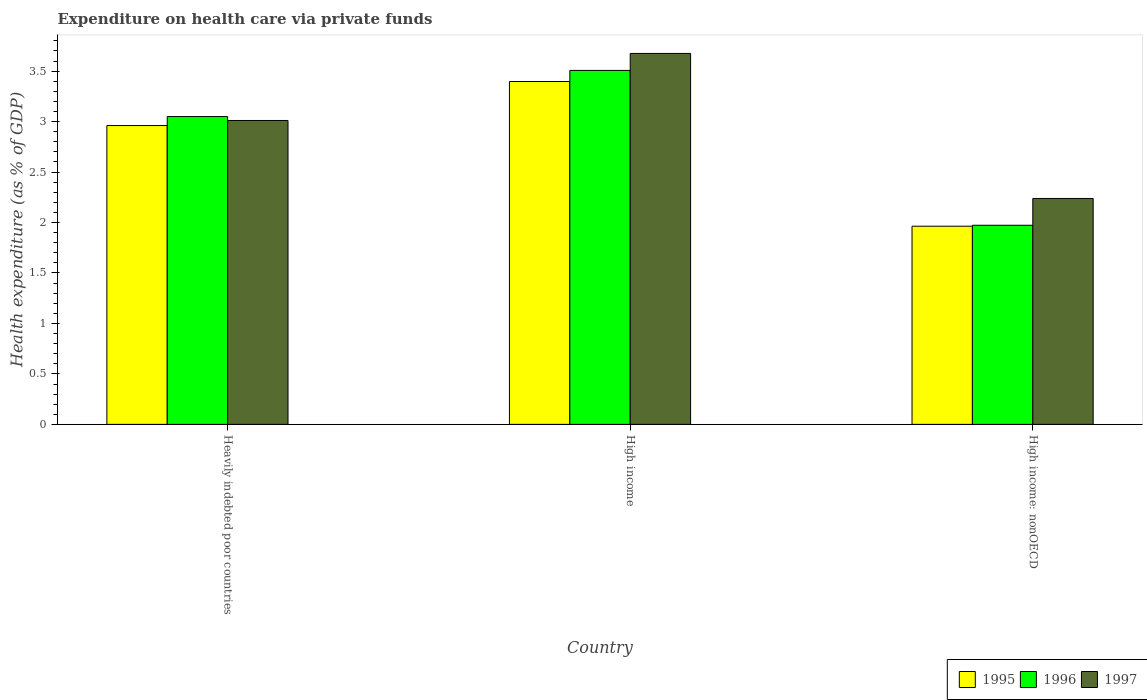How many groups of bars are there?
Your response must be concise. 3. Are the number of bars on each tick of the X-axis equal?
Ensure brevity in your answer.  Yes. How many bars are there on the 2nd tick from the left?
Provide a short and direct response. 3. How many bars are there on the 2nd tick from the right?
Offer a very short reply. 3. What is the label of the 2nd group of bars from the left?
Ensure brevity in your answer.  High income. In how many cases, is the number of bars for a given country not equal to the number of legend labels?
Your response must be concise. 0. What is the expenditure made on health care in 1997 in Heavily indebted poor countries?
Your response must be concise. 3.01. Across all countries, what is the maximum expenditure made on health care in 1997?
Your response must be concise. 3.68. Across all countries, what is the minimum expenditure made on health care in 1997?
Offer a very short reply. 2.24. In which country was the expenditure made on health care in 1995 minimum?
Your answer should be compact. High income: nonOECD. What is the total expenditure made on health care in 1996 in the graph?
Ensure brevity in your answer.  8.53. What is the difference between the expenditure made on health care in 1996 in High income and that in High income: nonOECD?
Ensure brevity in your answer.  1.53. What is the difference between the expenditure made on health care in 1996 in Heavily indebted poor countries and the expenditure made on health care in 1997 in High income: nonOECD?
Provide a short and direct response. 0.81. What is the average expenditure made on health care in 1997 per country?
Ensure brevity in your answer.  2.98. What is the difference between the expenditure made on health care of/in 1996 and expenditure made on health care of/in 1995 in Heavily indebted poor countries?
Provide a short and direct response. 0.09. In how many countries, is the expenditure made on health care in 1996 greater than 1.5 %?
Provide a short and direct response. 3. What is the ratio of the expenditure made on health care in 1995 in Heavily indebted poor countries to that in High income?
Ensure brevity in your answer.  0.87. Is the expenditure made on health care in 1995 in Heavily indebted poor countries less than that in High income: nonOECD?
Make the answer very short. No. Is the difference between the expenditure made on health care in 1996 in Heavily indebted poor countries and High income: nonOECD greater than the difference between the expenditure made on health care in 1995 in Heavily indebted poor countries and High income: nonOECD?
Give a very brief answer. Yes. What is the difference between the highest and the second highest expenditure made on health care in 1995?
Give a very brief answer. -1. What is the difference between the highest and the lowest expenditure made on health care in 1996?
Your answer should be very brief. 1.53. In how many countries, is the expenditure made on health care in 1996 greater than the average expenditure made on health care in 1996 taken over all countries?
Offer a terse response. 2. Is the sum of the expenditure made on health care in 1996 in High income and High income: nonOECD greater than the maximum expenditure made on health care in 1995 across all countries?
Your answer should be compact. Yes. What does the 2nd bar from the right in Heavily indebted poor countries represents?
Provide a succinct answer. 1996. Is it the case that in every country, the sum of the expenditure made on health care in 1995 and expenditure made on health care in 1996 is greater than the expenditure made on health care in 1997?
Provide a short and direct response. Yes. Are all the bars in the graph horizontal?
Your answer should be very brief. No. How many countries are there in the graph?
Provide a succinct answer. 3. Does the graph contain grids?
Offer a terse response. No. Where does the legend appear in the graph?
Your answer should be very brief. Bottom right. How many legend labels are there?
Make the answer very short. 3. What is the title of the graph?
Provide a succinct answer. Expenditure on health care via private funds. Does "2012" appear as one of the legend labels in the graph?
Offer a terse response. No. What is the label or title of the Y-axis?
Give a very brief answer. Health expenditure (as % of GDP). What is the Health expenditure (as % of GDP) in 1995 in Heavily indebted poor countries?
Offer a very short reply. 2.96. What is the Health expenditure (as % of GDP) in 1996 in Heavily indebted poor countries?
Offer a very short reply. 3.05. What is the Health expenditure (as % of GDP) in 1997 in Heavily indebted poor countries?
Provide a short and direct response. 3.01. What is the Health expenditure (as % of GDP) in 1995 in High income?
Offer a terse response. 3.4. What is the Health expenditure (as % of GDP) of 1996 in High income?
Your answer should be compact. 3.51. What is the Health expenditure (as % of GDP) of 1997 in High income?
Your response must be concise. 3.68. What is the Health expenditure (as % of GDP) of 1995 in High income: nonOECD?
Provide a short and direct response. 1.96. What is the Health expenditure (as % of GDP) of 1996 in High income: nonOECD?
Your answer should be very brief. 1.97. What is the Health expenditure (as % of GDP) in 1997 in High income: nonOECD?
Keep it short and to the point. 2.24. Across all countries, what is the maximum Health expenditure (as % of GDP) of 1995?
Offer a terse response. 3.4. Across all countries, what is the maximum Health expenditure (as % of GDP) of 1996?
Ensure brevity in your answer.  3.51. Across all countries, what is the maximum Health expenditure (as % of GDP) in 1997?
Provide a short and direct response. 3.68. Across all countries, what is the minimum Health expenditure (as % of GDP) in 1995?
Ensure brevity in your answer.  1.96. Across all countries, what is the minimum Health expenditure (as % of GDP) in 1996?
Make the answer very short. 1.97. Across all countries, what is the minimum Health expenditure (as % of GDP) in 1997?
Give a very brief answer. 2.24. What is the total Health expenditure (as % of GDP) of 1995 in the graph?
Ensure brevity in your answer.  8.32. What is the total Health expenditure (as % of GDP) in 1996 in the graph?
Your answer should be very brief. 8.53. What is the total Health expenditure (as % of GDP) of 1997 in the graph?
Make the answer very short. 8.93. What is the difference between the Health expenditure (as % of GDP) in 1995 in Heavily indebted poor countries and that in High income?
Your answer should be compact. -0.44. What is the difference between the Health expenditure (as % of GDP) of 1996 in Heavily indebted poor countries and that in High income?
Offer a terse response. -0.46. What is the difference between the Health expenditure (as % of GDP) of 1997 in Heavily indebted poor countries and that in High income?
Offer a very short reply. -0.66. What is the difference between the Health expenditure (as % of GDP) in 1997 in Heavily indebted poor countries and that in High income: nonOECD?
Provide a short and direct response. 0.77. What is the difference between the Health expenditure (as % of GDP) of 1995 in High income and that in High income: nonOECD?
Provide a short and direct response. 1.43. What is the difference between the Health expenditure (as % of GDP) of 1996 in High income and that in High income: nonOECD?
Your answer should be very brief. 1.53. What is the difference between the Health expenditure (as % of GDP) in 1997 in High income and that in High income: nonOECD?
Offer a very short reply. 1.44. What is the difference between the Health expenditure (as % of GDP) of 1995 in Heavily indebted poor countries and the Health expenditure (as % of GDP) of 1996 in High income?
Provide a succinct answer. -0.55. What is the difference between the Health expenditure (as % of GDP) of 1995 in Heavily indebted poor countries and the Health expenditure (as % of GDP) of 1997 in High income?
Keep it short and to the point. -0.71. What is the difference between the Health expenditure (as % of GDP) of 1996 in Heavily indebted poor countries and the Health expenditure (as % of GDP) of 1997 in High income?
Give a very brief answer. -0.63. What is the difference between the Health expenditure (as % of GDP) of 1995 in Heavily indebted poor countries and the Health expenditure (as % of GDP) of 1996 in High income: nonOECD?
Give a very brief answer. 0.99. What is the difference between the Health expenditure (as % of GDP) in 1995 in Heavily indebted poor countries and the Health expenditure (as % of GDP) in 1997 in High income: nonOECD?
Provide a short and direct response. 0.72. What is the difference between the Health expenditure (as % of GDP) in 1996 in Heavily indebted poor countries and the Health expenditure (as % of GDP) in 1997 in High income: nonOECD?
Keep it short and to the point. 0.81. What is the difference between the Health expenditure (as % of GDP) of 1995 in High income and the Health expenditure (as % of GDP) of 1996 in High income: nonOECD?
Offer a very short reply. 1.42. What is the difference between the Health expenditure (as % of GDP) of 1995 in High income and the Health expenditure (as % of GDP) of 1997 in High income: nonOECD?
Provide a short and direct response. 1.16. What is the difference between the Health expenditure (as % of GDP) of 1996 in High income and the Health expenditure (as % of GDP) of 1997 in High income: nonOECD?
Provide a succinct answer. 1.27. What is the average Health expenditure (as % of GDP) of 1995 per country?
Offer a very short reply. 2.77. What is the average Health expenditure (as % of GDP) of 1996 per country?
Provide a short and direct response. 2.84. What is the average Health expenditure (as % of GDP) in 1997 per country?
Keep it short and to the point. 2.98. What is the difference between the Health expenditure (as % of GDP) of 1995 and Health expenditure (as % of GDP) of 1996 in Heavily indebted poor countries?
Make the answer very short. -0.09. What is the difference between the Health expenditure (as % of GDP) of 1995 and Health expenditure (as % of GDP) of 1997 in Heavily indebted poor countries?
Your answer should be very brief. -0.05. What is the difference between the Health expenditure (as % of GDP) of 1996 and Health expenditure (as % of GDP) of 1997 in Heavily indebted poor countries?
Make the answer very short. 0.04. What is the difference between the Health expenditure (as % of GDP) of 1995 and Health expenditure (as % of GDP) of 1996 in High income?
Make the answer very short. -0.11. What is the difference between the Health expenditure (as % of GDP) in 1995 and Health expenditure (as % of GDP) in 1997 in High income?
Keep it short and to the point. -0.28. What is the difference between the Health expenditure (as % of GDP) of 1996 and Health expenditure (as % of GDP) of 1997 in High income?
Keep it short and to the point. -0.17. What is the difference between the Health expenditure (as % of GDP) in 1995 and Health expenditure (as % of GDP) in 1996 in High income: nonOECD?
Keep it short and to the point. -0.01. What is the difference between the Health expenditure (as % of GDP) in 1995 and Health expenditure (as % of GDP) in 1997 in High income: nonOECD?
Offer a very short reply. -0.27. What is the difference between the Health expenditure (as % of GDP) in 1996 and Health expenditure (as % of GDP) in 1997 in High income: nonOECD?
Make the answer very short. -0.27. What is the ratio of the Health expenditure (as % of GDP) in 1995 in Heavily indebted poor countries to that in High income?
Ensure brevity in your answer.  0.87. What is the ratio of the Health expenditure (as % of GDP) of 1996 in Heavily indebted poor countries to that in High income?
Offer a very short reply. 0.87. What is the ratio of the Health expenditure (as % of GDP) of 1997 in Heavily indebted poor countries to that in High income?
Your response must be concise. 0.82. What is the ratio of the Health expenditure (as % of GDP) of 1995 in Heavily indebted poor countries to that in High income: nonOECD?
Offer a terse response. 1.51. What is the ratio of the Health expenditure (as % of GDP) in 1996 in Heavily indebted poor countries to that in High income: nonOECD?
Provide a succinct answer. 1.55. What is the ratio of the Health expenditure (as % of GDP) of 1997 in Heavily indebted poor countries to that in High income: nonOECD?
Your answer should be very brief. 1.35. What is the ratio of the Health expenditure (as % of GDP) in 1995 in High income to that in High income: nonOECD?
Your answer should be compact. 1.73. What is the ratio of the Health expenditure (as % of GDP) in 1996 in High income to that in High income: nonOECD?
Give a very brief answer. 1.78. What is the ratio of the Health expenditure (as % of GDP) of 1997 in High income to that in High income: nonOECD?
Offer a terse response. 1.64. What is the difference between the highest and the second highest Health expenditure (as % of GDP) in 1995?
Offer a terse response. 0.44. What is the difference between the highest and the second highest Health expenditure (as % of GDP) in 1996?
Make the answer very short. 0.46. What is the difference between the highest and the second highest Health expenditure (as % of GDP) of 1997?
Provide a succinct answer. 0.66. What is the difference between the highest and the lowest Health expenditure (as % of GDP) in 1995?
Ensure brevity in your answer.  1.43. What is the difference between the highest and the lowest Health expenditure (as % of GDP) in 1996?
Make the answer very short. 1.53. What is the difference between the highest and the lowest Health expenditure (as % of GDP) of 1997?
Provide a short and direct response. 1.44. 